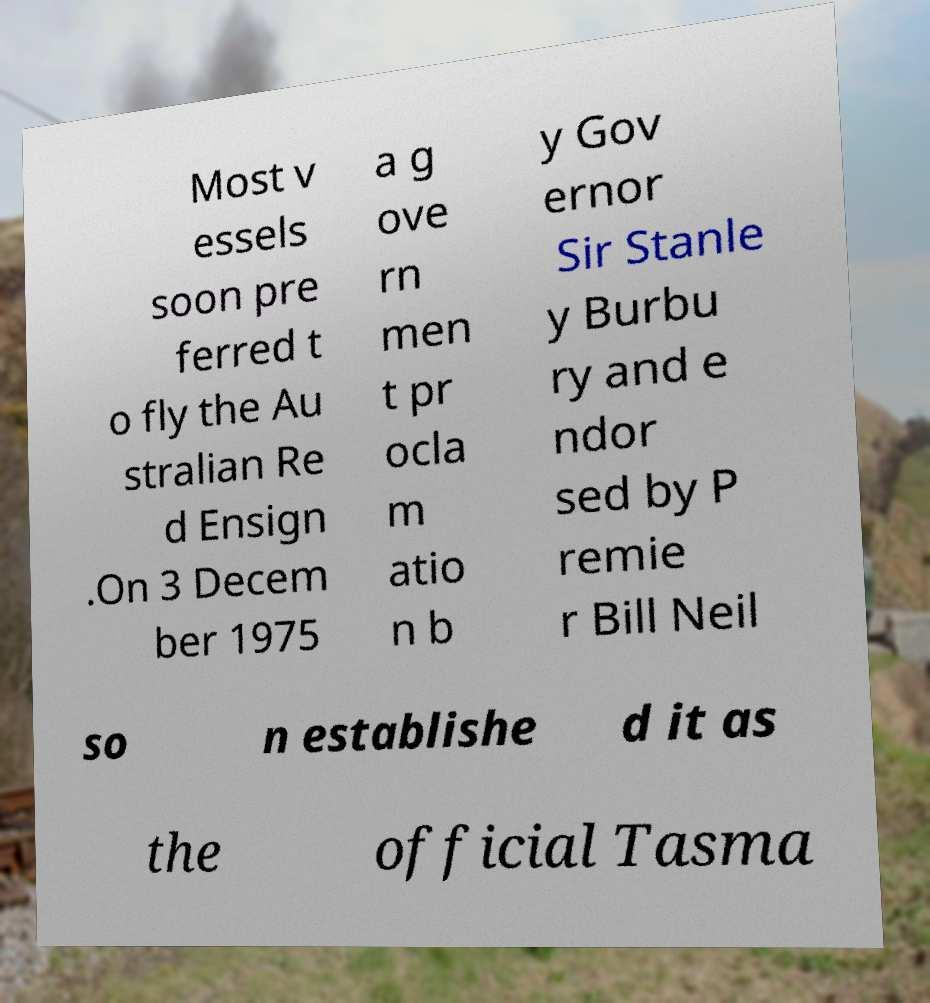Please read and relay the text visible in this image. What does it say? Most v essels soon pre ferred t o fly the Au stralian Re d Ensign .On 3 Decem ber 1975 a g ove rn men t pr ocla m atio n b y Gov ernor Sir Stanle y Burbu ry and e ndor sed by P remie r Bill Neil so n establishe d it as the official Tasma 